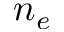Convert formula to latex. <formula><loc_0><loc_0><loc_500><loc_500>n _ { e }</formula> 